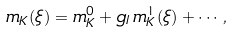<formula> <loc_0><loc_0><loc_500><loc_500>m _ { K } ( \xi ) = m _ { K } ^ { 0 } + g _ { I } \, m _ { K } ^ { 1 } ( \xi ) + \cdots ,</formula> 